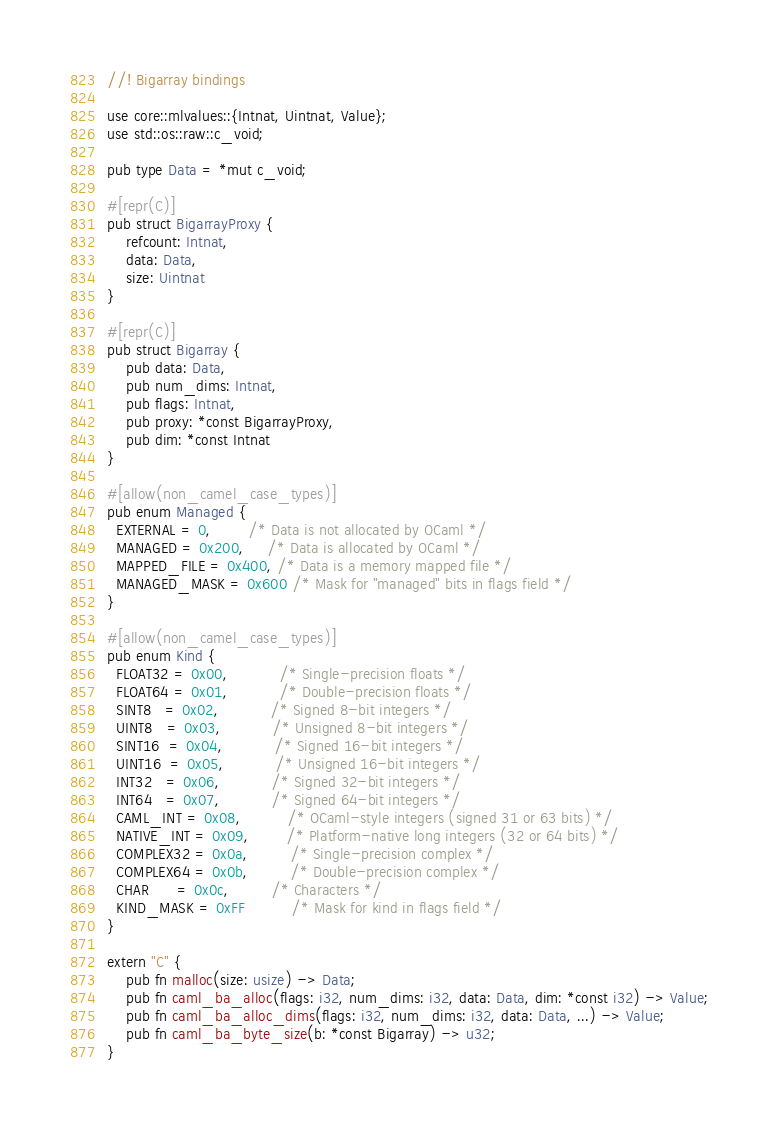Convert code to text. <code><loc_0><loc_0><loc_500><loc_500><_Rust_>//! Bigarray bindings

use core::mlvalues::{Intnat, Uintnat, Value};
use std::os::raw::c_void;

pub type Data = *mut c_void;

#[repr(C)]
pub struct BigarrayProxy {
    refcount: Intnat,
    data: Data,
    size: Uintnat
}

#[repr(C)]
pub struct Bigarray {
    pub data: Data,
    pub num_dims: Intnat,
    pub flags: Intnat,
    pub proxy: *const BigarrayProxy,
    pub dim: *const Intnat
}

#[allow(non_camel_case_types)]
pub enum Managed {
  EXTERNAL = 0,        /* Data is not allocated by OCaml */
  MANAGED = 0x200,     /* Data is allocated by OCaml */
  MAPPED_FILE = 0x400, /* Data is a memory mapped file */
  MANAGED_MASK = 0x600 /* Mask for "managed" bits in flags field */
}

#[allow(non_camel_case_types)]
pub enum Kind {
  FLOAT32 = 0x00,           /* Single-precision floats */
  FLOAT64 = 0x01,           /* Double-precision floats */
  SINT8   = 0x02,           /* Signed 8-bit integers */
  UINT8   = 0x03,           /* Unsigned 8-bit integers */
  SINT16  = 0x04,           /* Signed 16-bit integers */
  UINT16  = 0x05,           /* Unsigned 16-bit integers */
  INT32   = 0x06,           /* Signed 32-bit integers */
  INT64   = 0x07,           /* Signed 64-bit integers */
  CAML_INT = 0x08,          /* OCaml-style integers (signed 31 or 63 bits) */
  NATIVE_INT = 0x09,        /* Platform-native long integers (32 or 64 bits) */
  COMPLEX32 = 0x0a,         /* Single-precision complex */
  COMPLEX64 = 0x0b,         /* Double-precision complex */
  CHAR      = 0x0c,         /* Characters */
  KIND_MASK = 0xFF          /* Mask for kind in flags field */
}

extern "C" {
    pub fn malloc(size: usize) -> Data;
    pub fn caml_ba_alloc(flags: i32, num_dims: i32, data: Data, dim: *const i32) -> Value;
    pub fn caml_ba_alloc_dims(flags: i32, num_dims: i32, data: Data, ...) -> Value;
    pub fn caml_ba_byte_size(b: *const Bigarray) -> u32;
}
</code> 